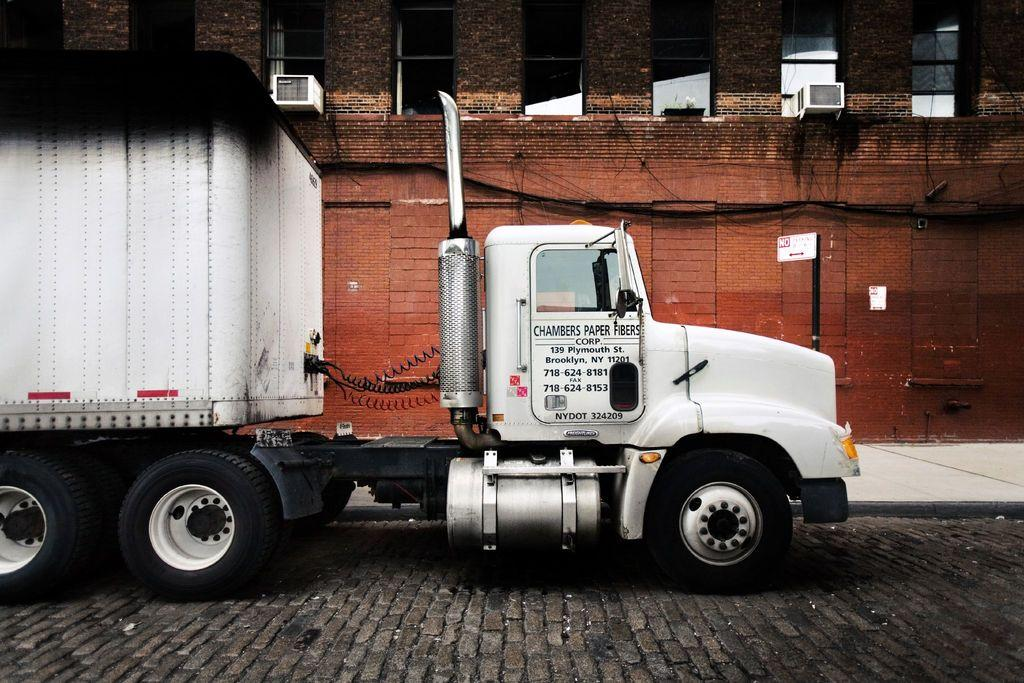What can be seen in the image that people walk or drive on? There is a path in the image that people can walk or drive on. What is located on the path in the image? There is a truck on the path. What is written on the truck in the image? Something is written on the truck. What can be seen in the background of the image? There is a building in the background of the image. How many windows are visible on the building in the image? There are multiple windows visible on the building. Can you tell me how much the plant costs in the image? There is no plant present in the image, so it is not possible to determine its cost. What type of haircut does the truck have in the image? The truck does not have a haircut, as it is an inanimate object. 